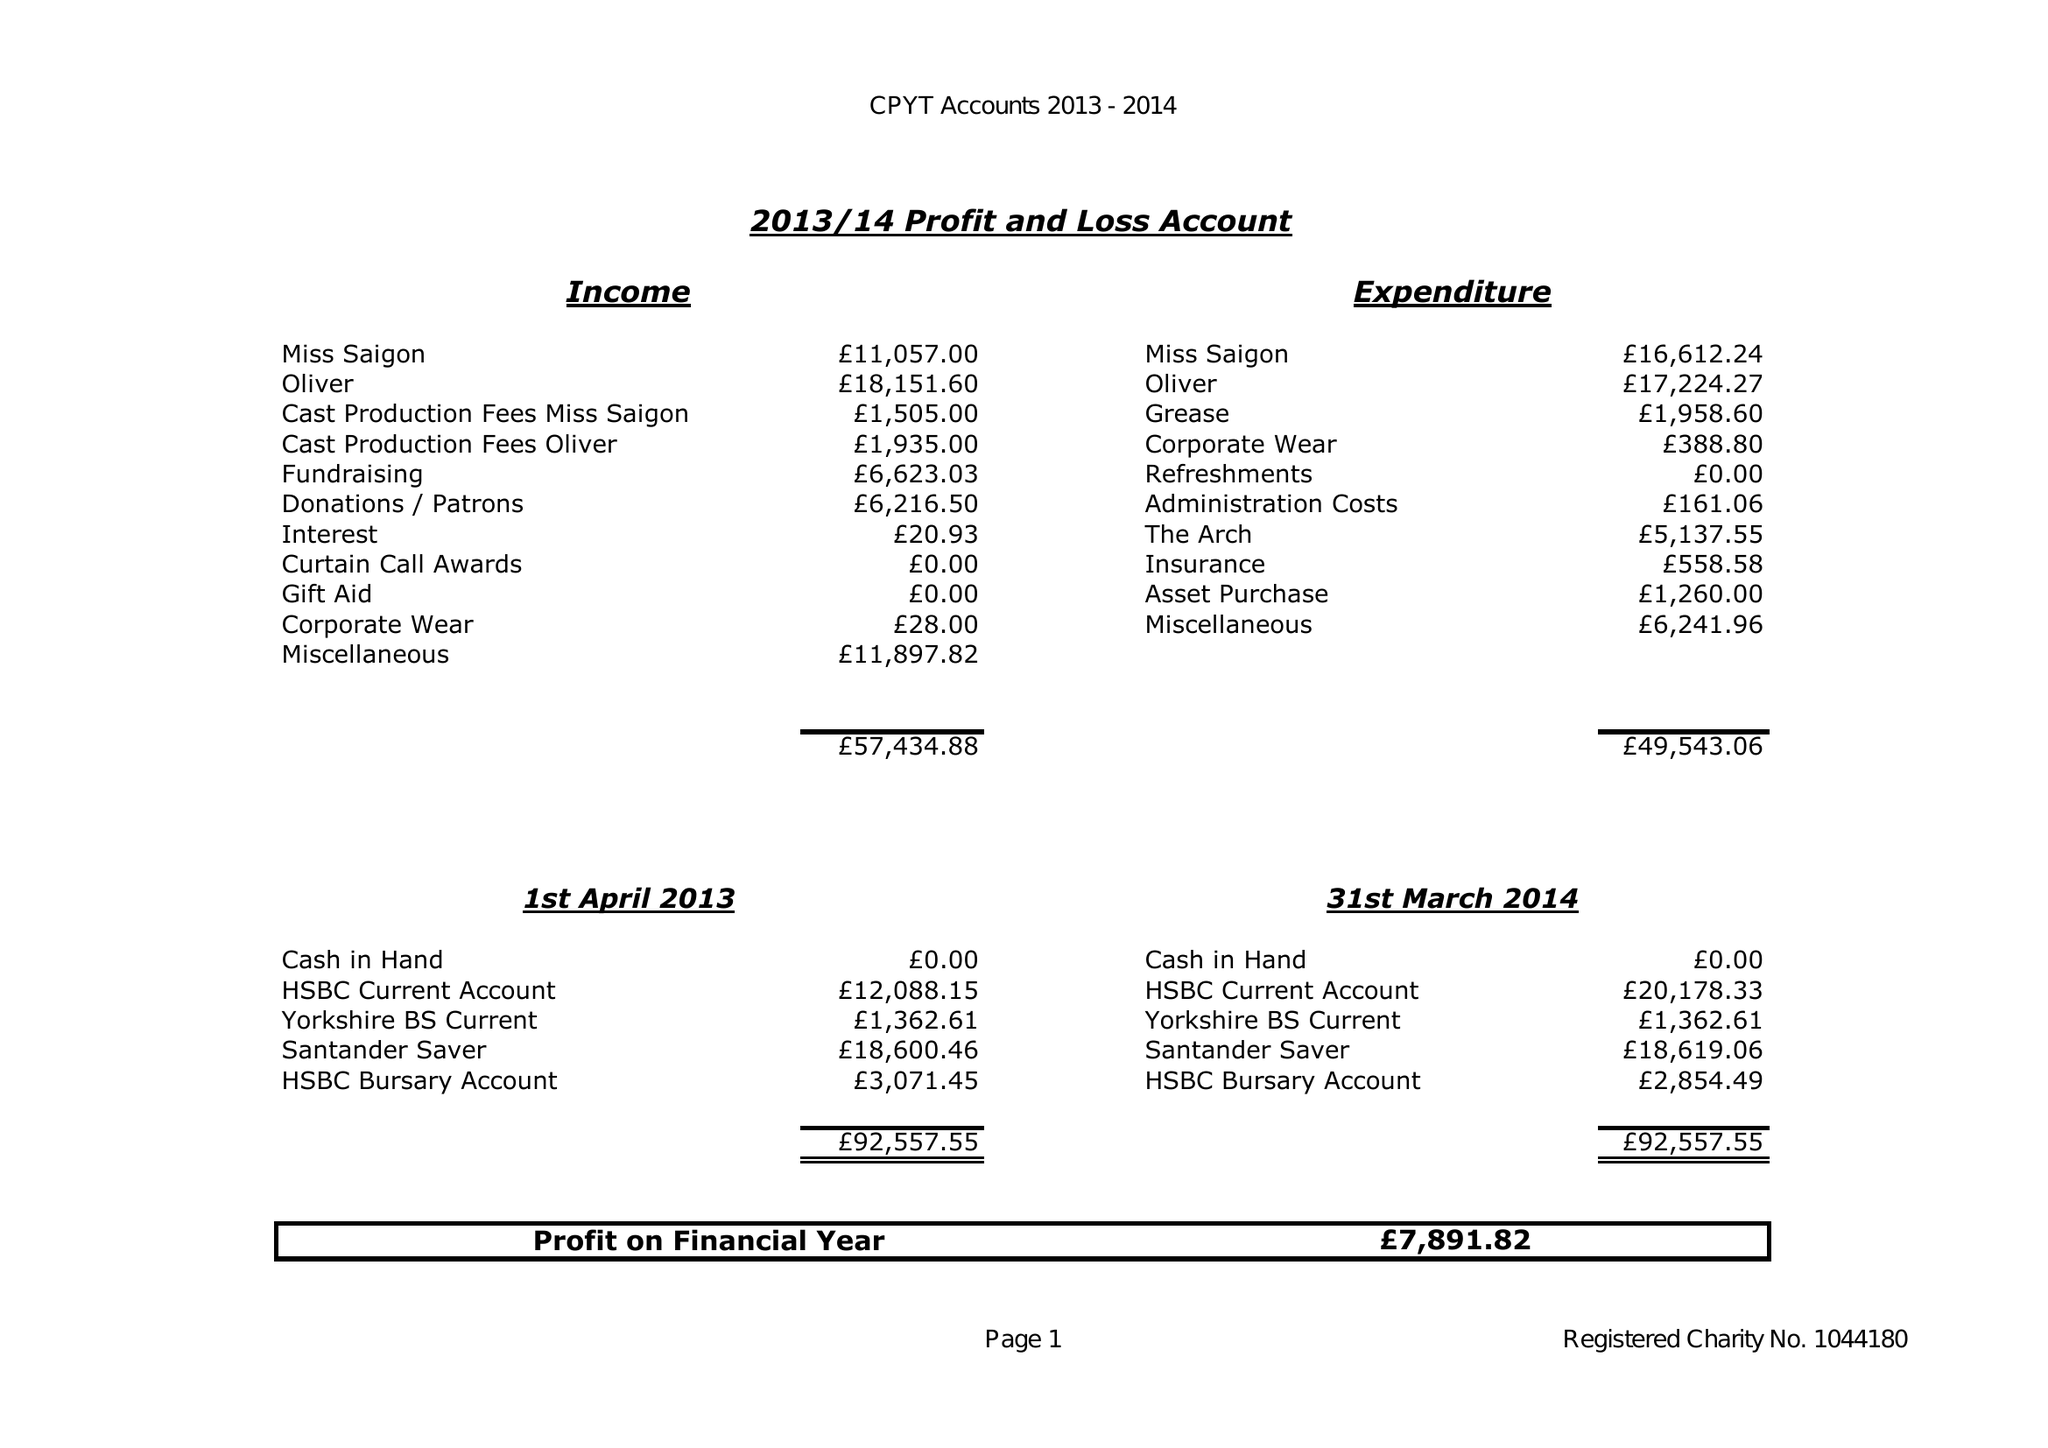What is the value for the charity_name?
Answer the question using a single word or phrase. Centrestage Productions Youth Theatre 